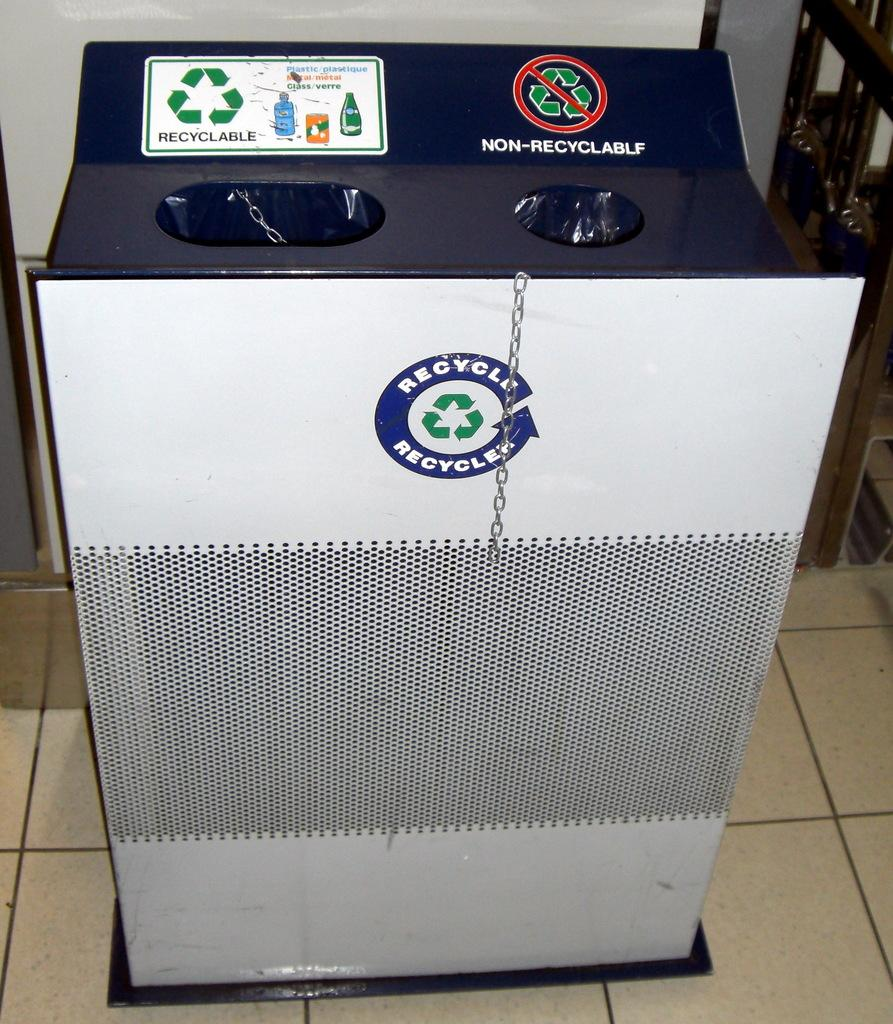<image>
Describe the image concisely. A garbage and recycling bin that has a recyclable and non recyclable side. 